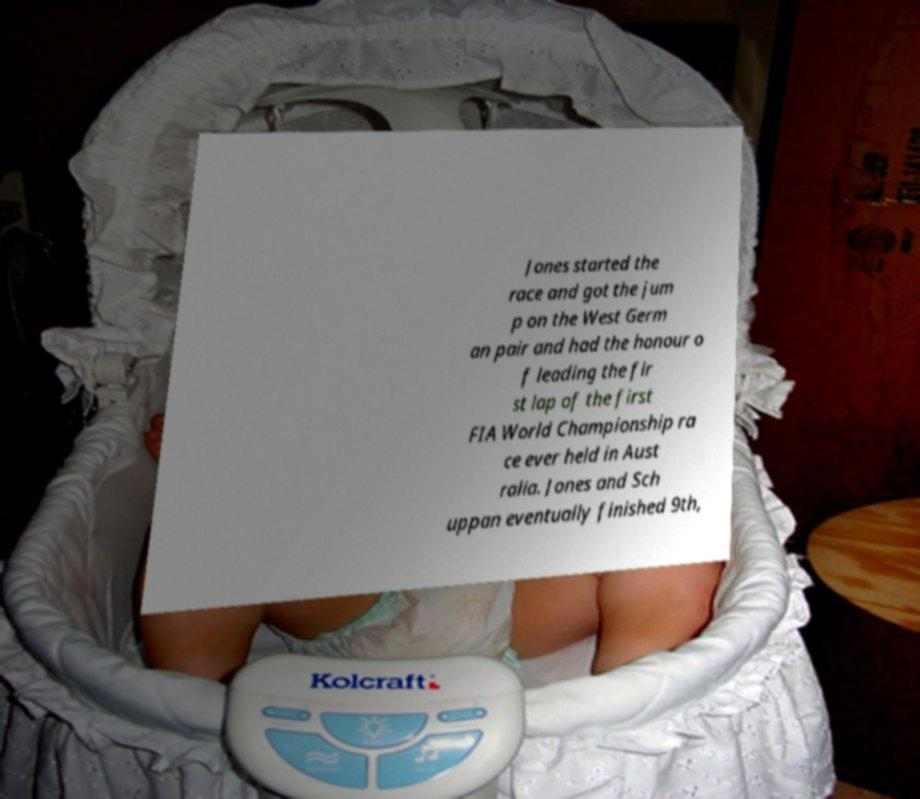Could you extract and type out the text from this image? Jones started the race and got the jum p on the West Germ an pair and had the honour o f leading the fir st lap of the first FIA World Championship ra ce ever held in Aust ralia. Jones and Sch uppan eventually finished 9th, 